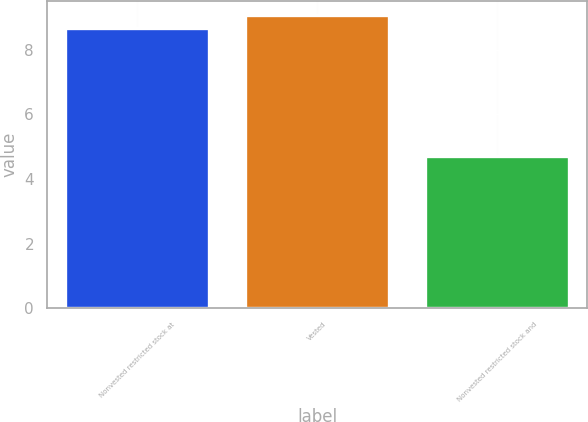Convert chart. <chart><loc_0><loc_0><loc_500><loc_500><bar_chart><fcel>Nonvested restricted stock at<fcel>Vested<fcel>Nonvested restricted stock and<nl><fcel>8.67<fcel>9.07<fcel>4.7<nl></chart> 